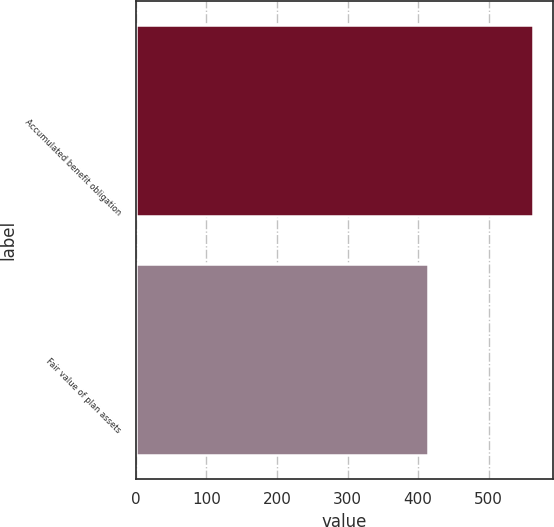Convert chart to OTSL. <chart><loc_0><loc_0><loc_500><loc_500><bar_chart><fcel>Accumulated benefit obligation<fcel>Fair value of plan assets<nl><fcel>563<fcel>414<nl></chart> 